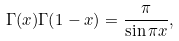<formula> <loc_0><loc_0><loc_500><loc_500>\Gamma ( x ) \Gamma ( 1 - x ) = \frac { \pi } { \sin \pi x } ,</formula> 